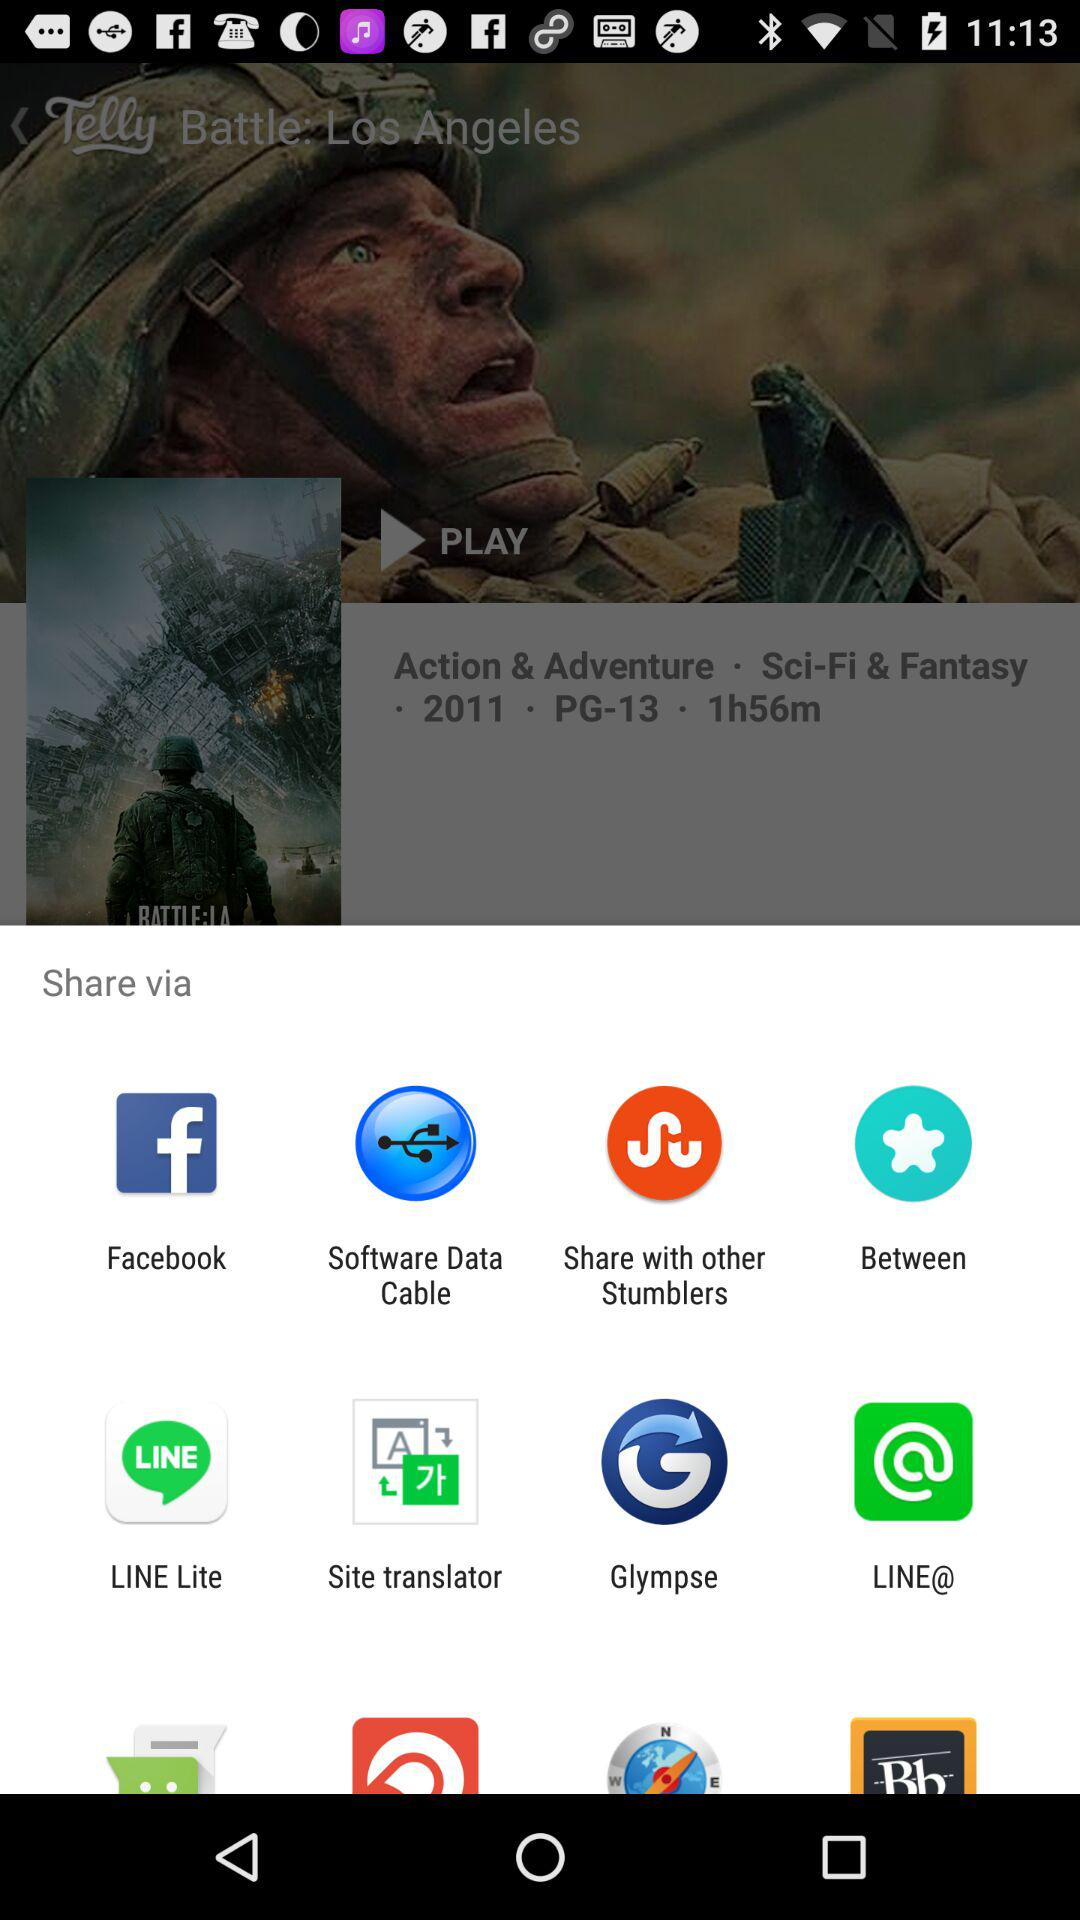What is the time duration of the film with the title "Battle: Los Angeles"? The time duration is 1 hour 56 minutes. 